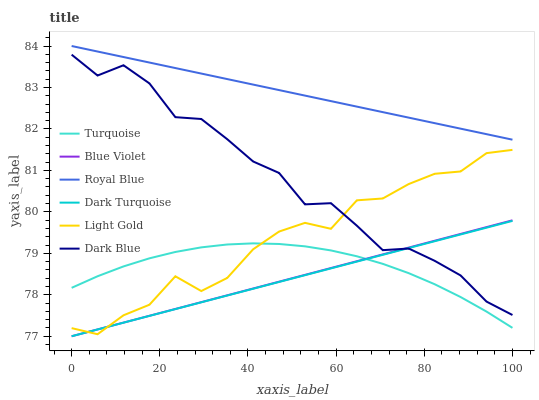Does Dark Blue have the minimum area under the curve?
Answer yes or no. No. Does Dark Blue have the maximum area under the curve?
Answer yes or no. No. Is Dark Blue the smoothest?
Answer yes or no. No. Is Dark Blue the roughest?
Answer yes or no. No. Does Dark Blue have the lowest value?
Answer yes or no. No. Does Dark Blue have the highest value?
Answer yes or no. No. Is Dark Blue less than Royal Blue?
Answer yes or no. Yes. Is Royal Blue greater than Dark Blue?
Answer yes or no. Yes. Does Dark Blue intersect Royal Blue?
Answer yes or no. No. 